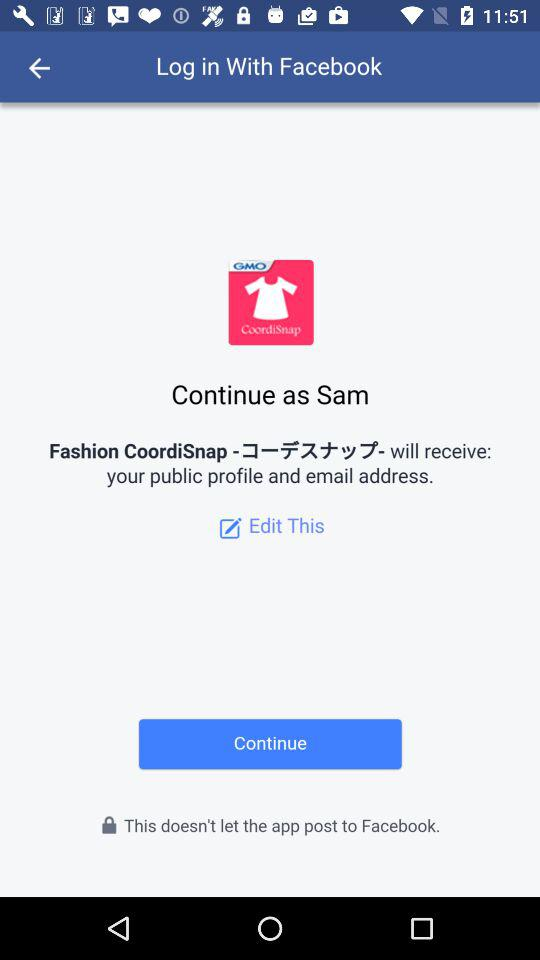What is the name of the user? The name of the user is Sam. 